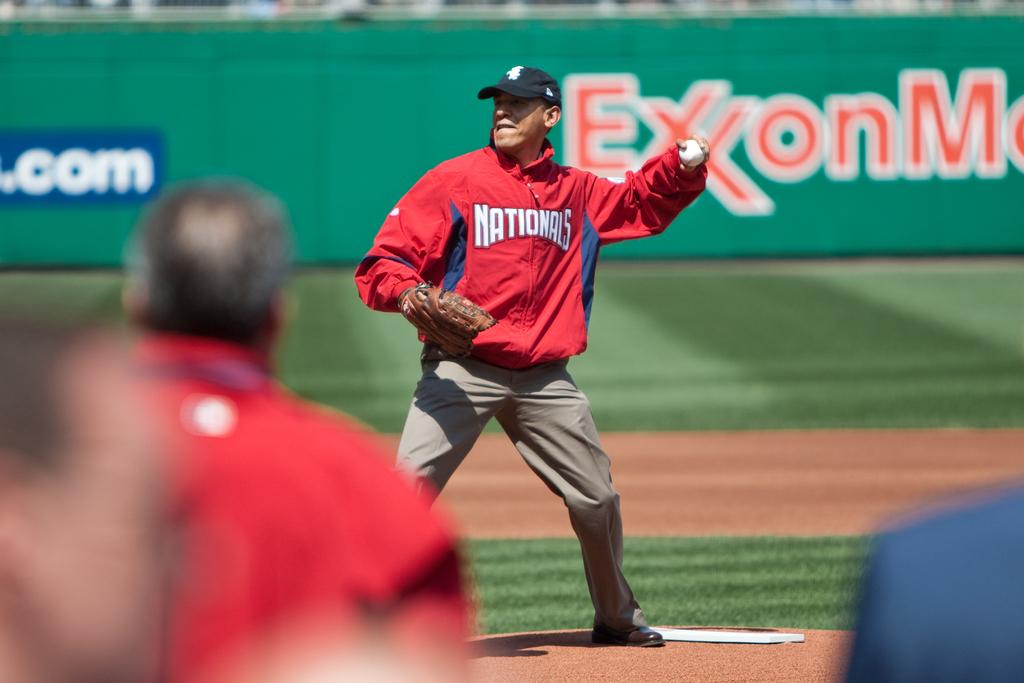What company is mentioned in red letters on the sign in the back?
Provide a succinct answer. Exxon. 